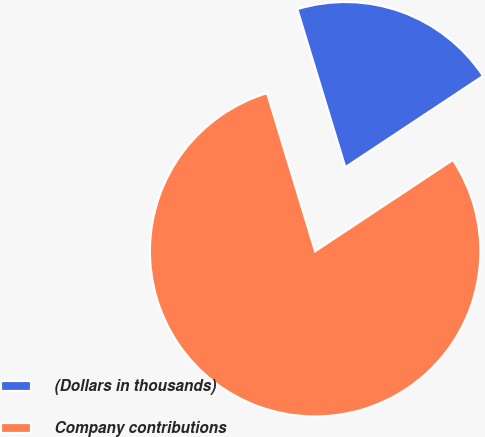<chart> <loc_0><loc_0><loc_500><loc_500><pie_chart><fcel>(Dollars in thousands)<fcel>Company contributions<nl><fcel>20.38%<fcel>79.62%<nl></chart> 